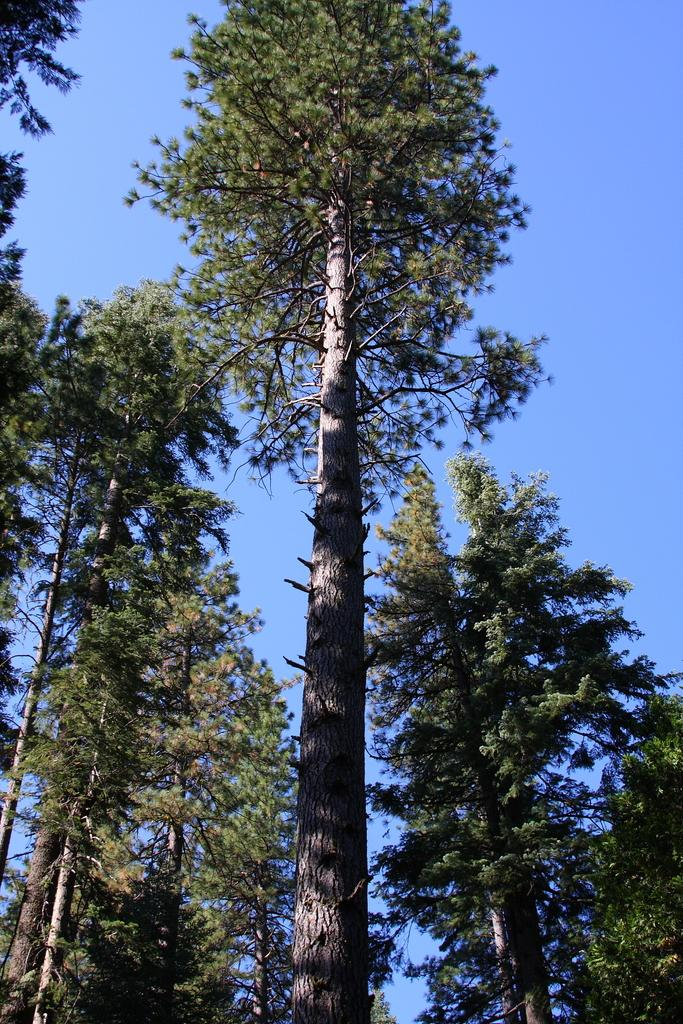What type of vegetation is present in the image? There are tall trees in the image. What color is the sky in the image? The sky is blue in the image. What type of creature can be seen swimming in the image? There is no creature present in the image; it only features tall trees and a blue sky. Is there a ship visible in the image? No, there is no ship present in the image. 